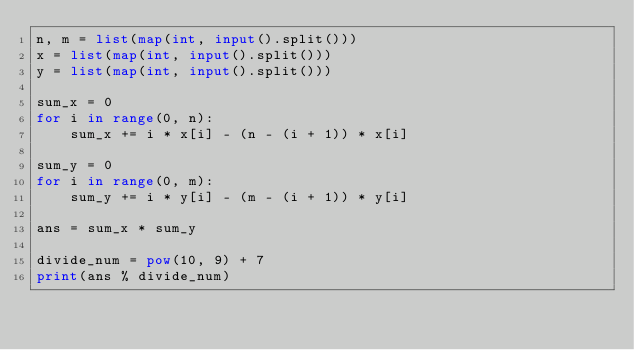Convert code to text. <code><loc_0><loc_0><loc_500><loc_500><_Python_>n, m = list(map(int, input().split()))
x = list(map(int, input().split()))
y = list(map(int, input().split()))

sum_x = 0
for i in range(0, n):
    sum_x += i * x[i] - (n - (i + 1)) * x[i]

sum_y = 0
for i in range(0, m):
    sum_y += i * y[i] - (m - (i + 1)) * y[i]

ans = sum_x * sum_y

divide_num = pow(10, 9) + 7
print(ans % divide_num)
</code> 